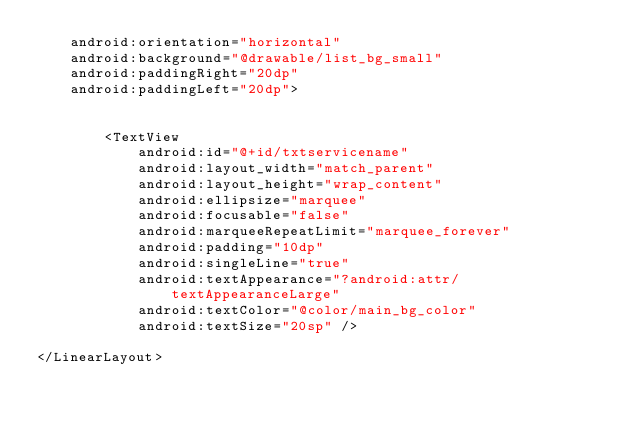<code> <loc_0><loc_0><loc_500><loc_500><_XML_>    android:orientation="horizontal"
    android:background="@drawable/list_bg_small"
    android:paddingRight="20dp"
    android:paddingLeft="20dp">


        <TextView
            android:id="@+id/txtservicename"
            android:layout_width="match_parent"
            android:layout_height="wrap_content"
            android:ellipsize="marquee"
            android:focusable="false"
            android:marqueeRepeatLimit="marquee_forever"
            android:padding="10dp"
            android:singleLine="true"
            android:textAppearance="?android:attr/textAppearanceLarge"
            android:textColor="@color/main_bg_color"
            android:textSize="20sp" />

</LinearLayout></code> 